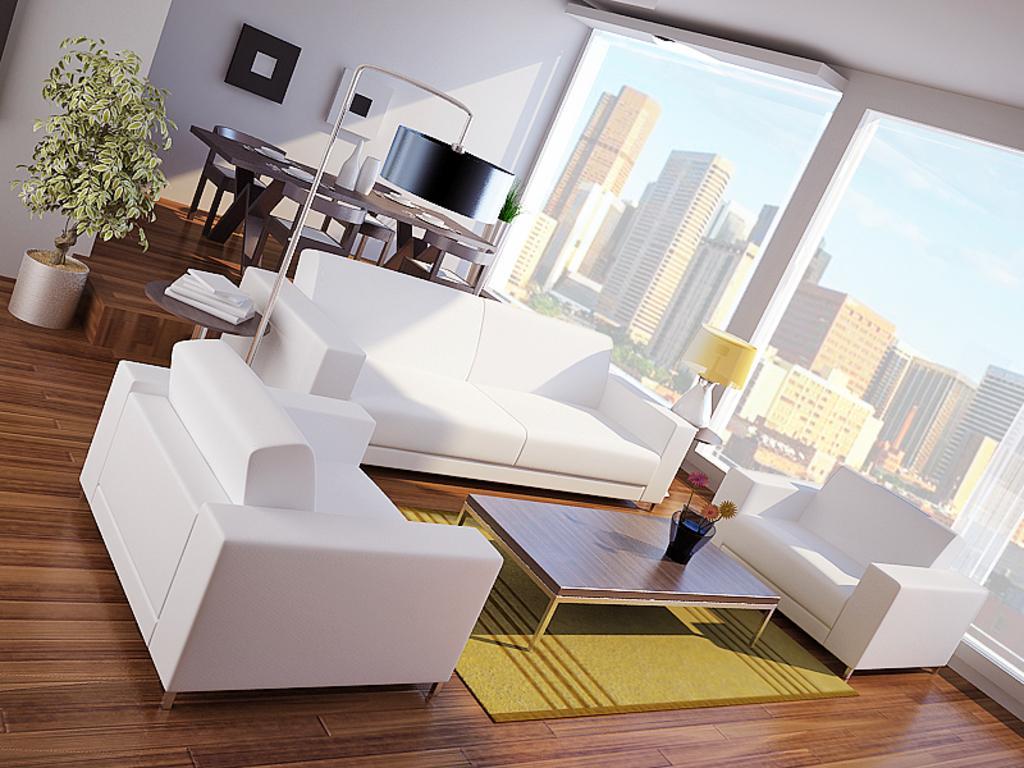Describe this image in one or two sentences. In this picture there is a sofa set in this room. There is a table in front of the sofas. In the background there is a dining table plants and a wall here. We can observe some buildings through this window. 